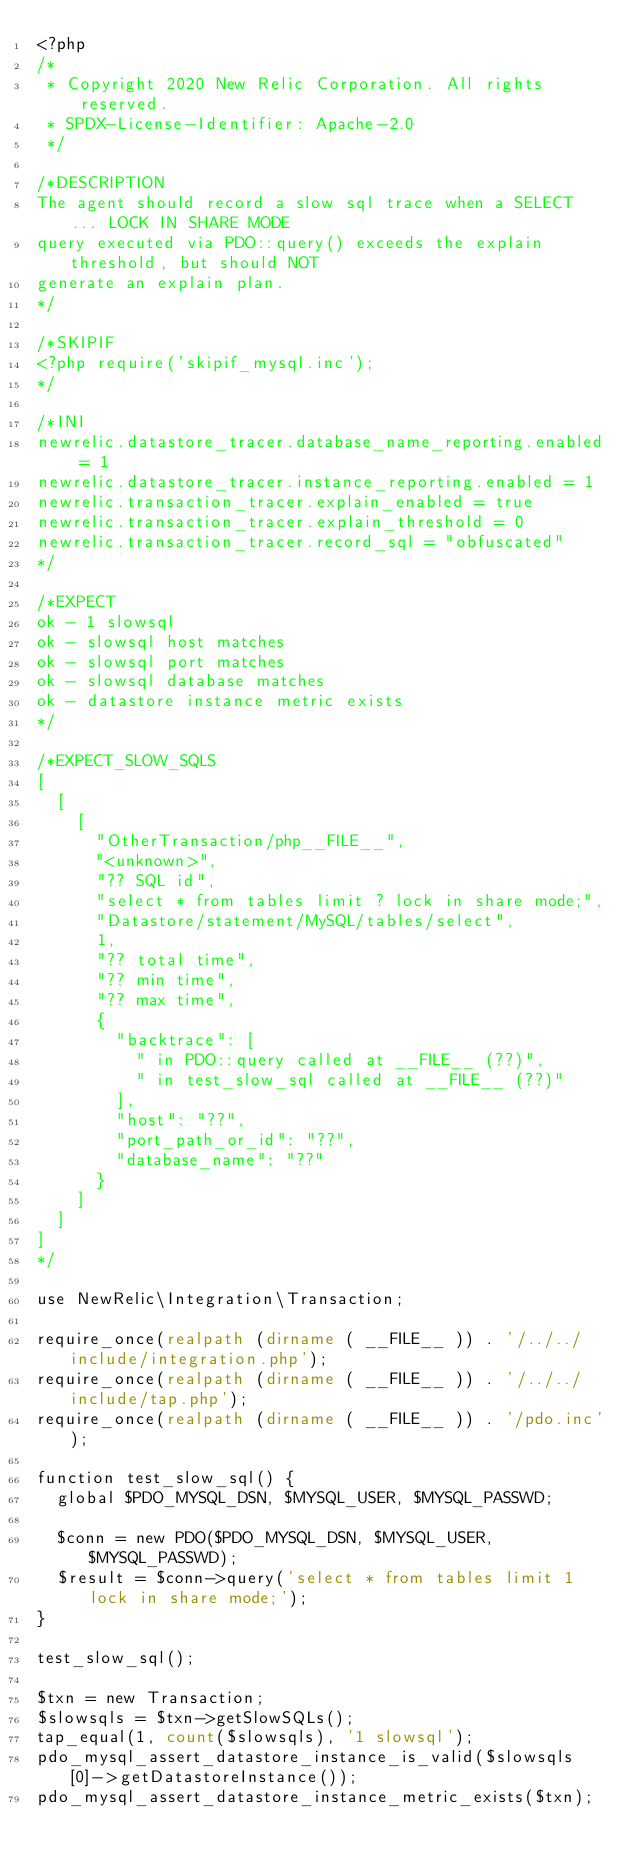Convert code to text. <code><loc_0><loc_0><loc_500><loc_500><_PHP_><?php
/*
 * Copyright 2020 New Relic Corporation. All rights reserved.
 * SPDX-License-Identifier: Apache-2.0
 */

/*DESCRIPTION
The agent should record a slow sql trace when a SELECT ... LOCK IN SHARE MODE
query executed via PDO::query() exceeds the explain threshold, but should NOT
generate an explain plan.
*/

/*SKIPIF
<?php require('skipif_mysql.inc');
*/

/*INI
newrelic.datastore_tracer.database_name_reporting.enabled = 1
newrelic.datastore_tracer.instance_reporting.enabled = 1
newrelic.transaction_tracer.explain_enabled = true
newrelic.transaction_tracer.explain_threshold = 0
newrelic.transaction_tracer.record_sql = "obfuscated" 
*/

/*EXPECT
ok - 1 slowsql
ok - slowsql host matches
ok - slowsql port matches
ok - slowsql database matches
ok - datastore instance metric exists
*/

/*EXPECT_SLOW_SQLS
[
  [
    [
      "OtherTransaction/php__FILE__",
      "<unknown>",
      "?? SQL id",
      "select * from tables limit ? lock in share mode;",
      "Datastore/statement/MySQL/tables/select",
      1,
      "?? total time",
      "?? min time",
      "?? max time",
      {
        "backtrace": [
          " in PDO::query called at __FILE__ (??)",
          " in test_slow_sql called at __FILE__ (??)"
        ],
        "host": "??",
        "port_path_or_id": "??",
        "database_name": "??"
      }
    ]
  ]
]
*/

use NewRelic\Integration\Transaction;

require_once(realpath (dirname ( __FILE__ )) . '/../../include/integration.php');
require_once(realpath (dirname ( __FILE__ )) . '/../../include/tap.php');
require_once(realpath (dirname ( __FILE__ )) . '/pdo.inc');

function test_slow_sql() {
  global $PDO_MYSQL_DSN, $MYSQL_USER, $MYSQL_PASSWD;

  $conn = new PDO($PDO_MYSQL_DSN, $MYSQL_USER, $MYSQL_PASSWD);
  $result = $conn->query('select * from tables limit 1 lock in share mode;');
}

test_slow_sql();

$txn = new Transaction;
$slowsqls = $txn->getSlowSQLs();
tap_equal(1, count($slowsqls), '1 slowsql');
pdo_mysql_assert_datastore_instance_is_valid($slowsqls[0]->getDatastoreInstance());
pdo_mysql_assert_datastore_instance_metric_exists($txn);
</code> 